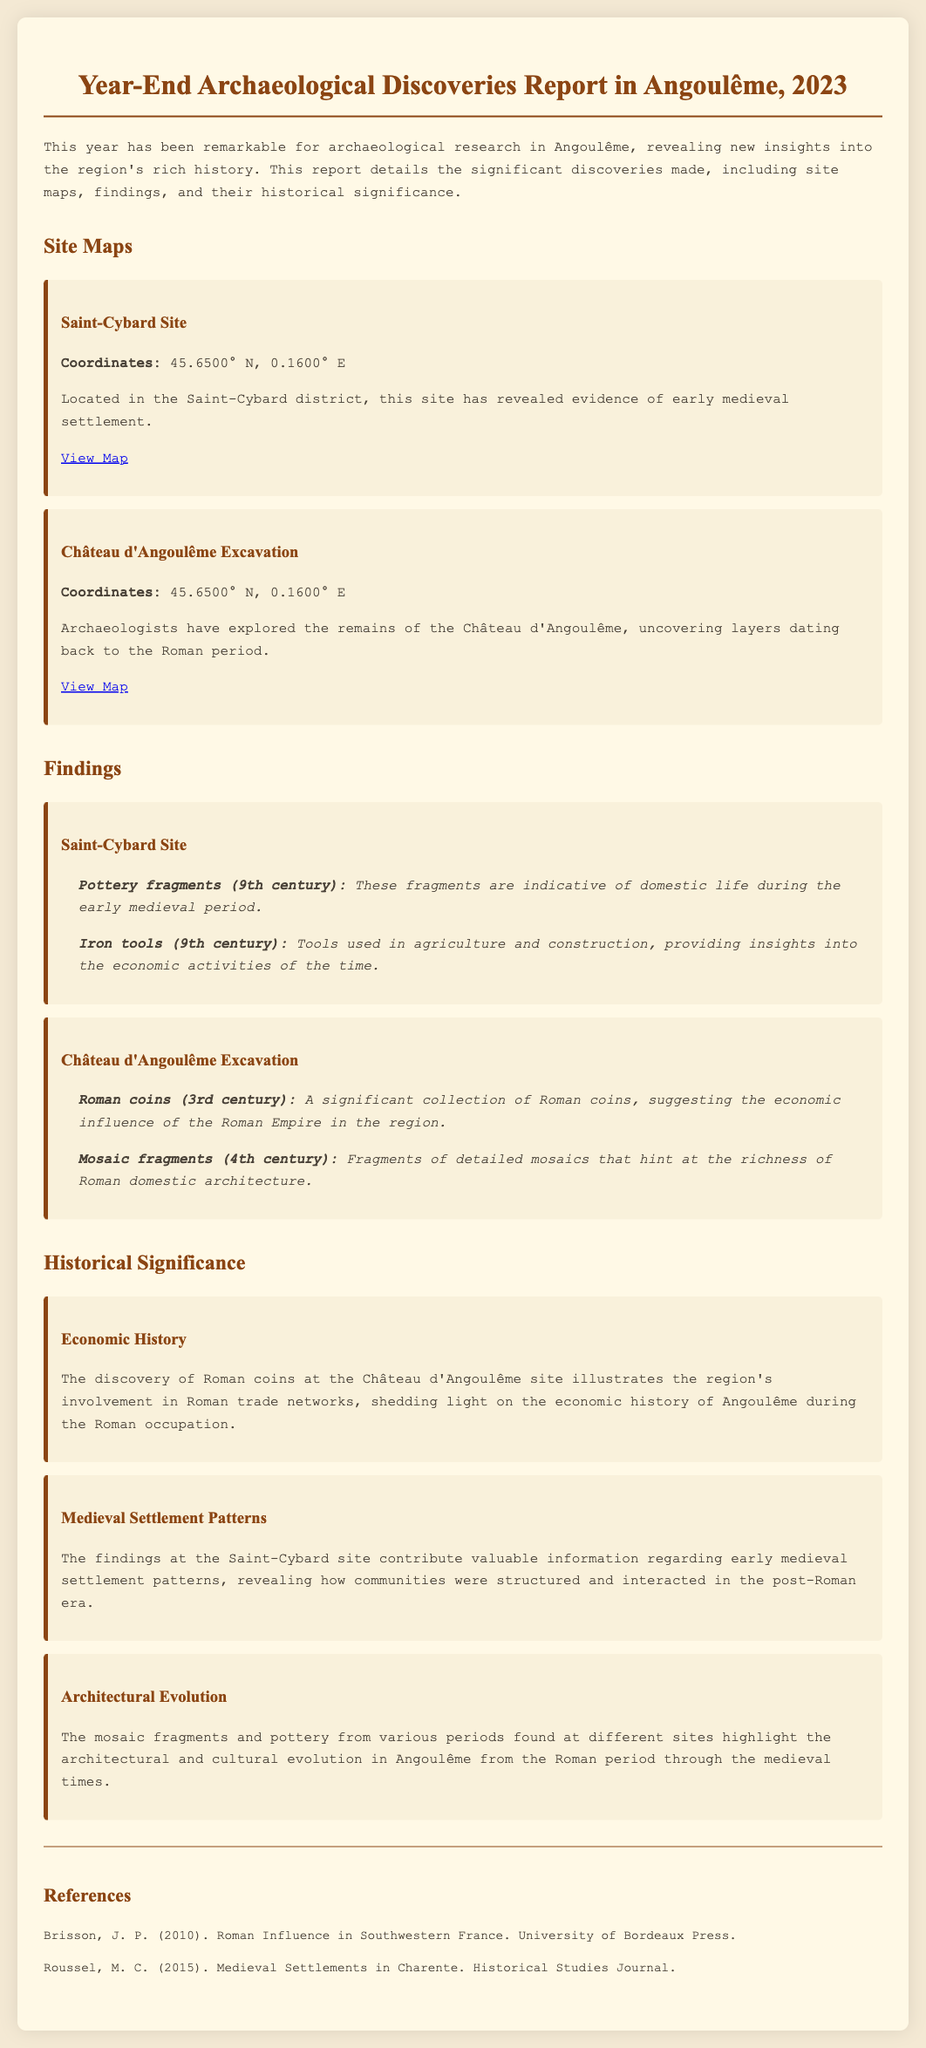What is the title of the report? The title of the report is provided in the header of the document, which states "Year-End Archaeological Discoveries Report in Angoulême, 2023."
Answer: Year-End Archaeological Discoveries Report in Angoulême, 2023 What is the coordinate of the Saint-Cybard site? The coordinates for the Saint-Cybard site are mentioned directly under the site description, listed as "45.6500° N, 0.1600° E."
Answer: 45.6500° N, 0.1600° E Which artifacts were found at the Saint-Cybard site? The document specifies two artifacts, 'Pottery fragments' and 'Iron tools,' found at the Saint-Cybard site.
Answer: Pottery fragments, Iron tools What century do the Roman coins found belong to? The document states that the Roman coins found are from the 3rd century, as mentioned in the findings section.
Answer: 3rd century What is highlighted as the historical significance of the findings at the Château d'Angoulême? The historical significance centers around the economic history related to Roman trade networks, as outlined in the significance section.
Answer: Economic history How many artifacts were detailed from the Château d'Angoulême excavation? Two artifacts are documented from the Château d'Angoulême excavation, namely Roman coins and mosaic fragments.
Answer: Two artifacts What does the document mention regarding architectural evolution? The historical significance of architectural evolution is discussed, highlighting the changes from the Roman period through medieval times.
Answer: Architectural evolution Which reference discusses medieval settlements? The reference authored by M. C. Roussel in 2015 discusses medieval settlements in Charente, as listed in the references section.
Answer: Medieval Settlements in Charente What are the two site maps provided in the report? The report lists the site maps for the 'Saint-Cybard Site' and 'Château d'Angoulême Excavation.'
Answer: Saint-Cybard Site, Château d'Angoulême Excavation 